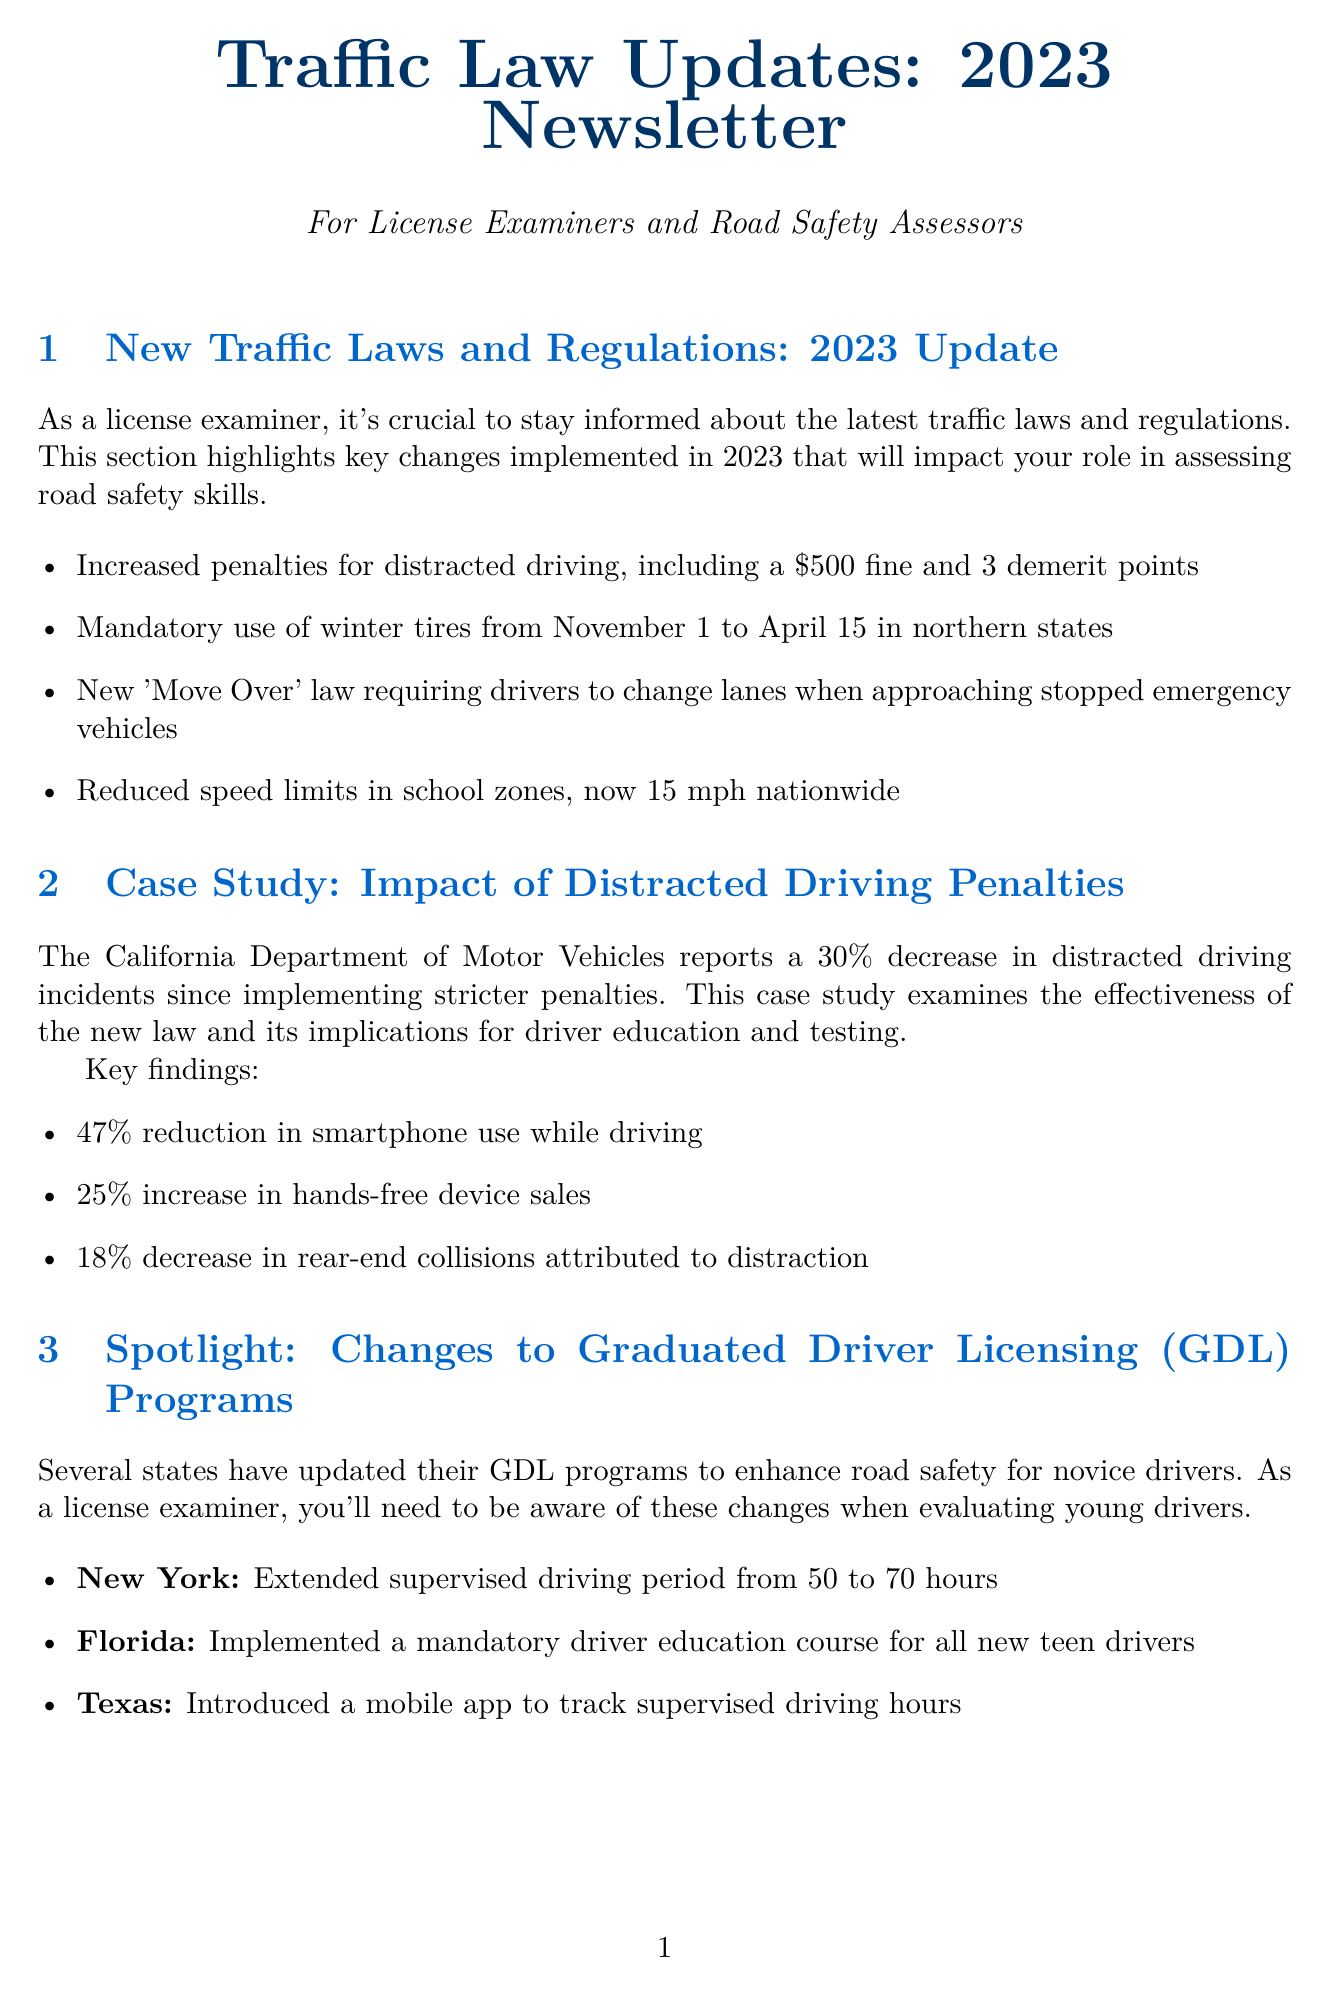What are the penalties for distracted driving? The penalties for distracted driving include a $500 fine and 3 demerit points.
Answer: $500 fine and 3 demerit points What is the mandatory period for using winter tires in northern states? Winter tires must be used from November 1 to April 15 in northern states.
Answer: November 1 to April 15 What percentage of reduction in smartphone use while driving was reported? The key finding reports a 47% reduction in smartphone use while driving since implementing stricter penalties.
Answer: 47% Which state extended the supervised driving period for GDL? New York extended the supervised driving period from 50 to 70 hours.
Answer: New York What is the date of the upcoming webinar? The upcoming webinar is scheduled for July 15, 2023.
Answer: July 15, 2023 What new tool monitors route adherence during road tests? DriveTrack Pro is the tool that monitors route adherence and speed limit compliance during road tests.
Answer: DriveTrack Pro What is the primary focus of the case study on distracted driving? The case study examines the effectiveness of the new law on distracted driving penalties and its implications for driver education and testing.
Answer: Effectiveness of the new law What is the name of the speaker at the upcoming webinar? The speaker at the upcoming webinar is Dr. Sarah Johnson.
Answer: Dr. Sarah Johnson 